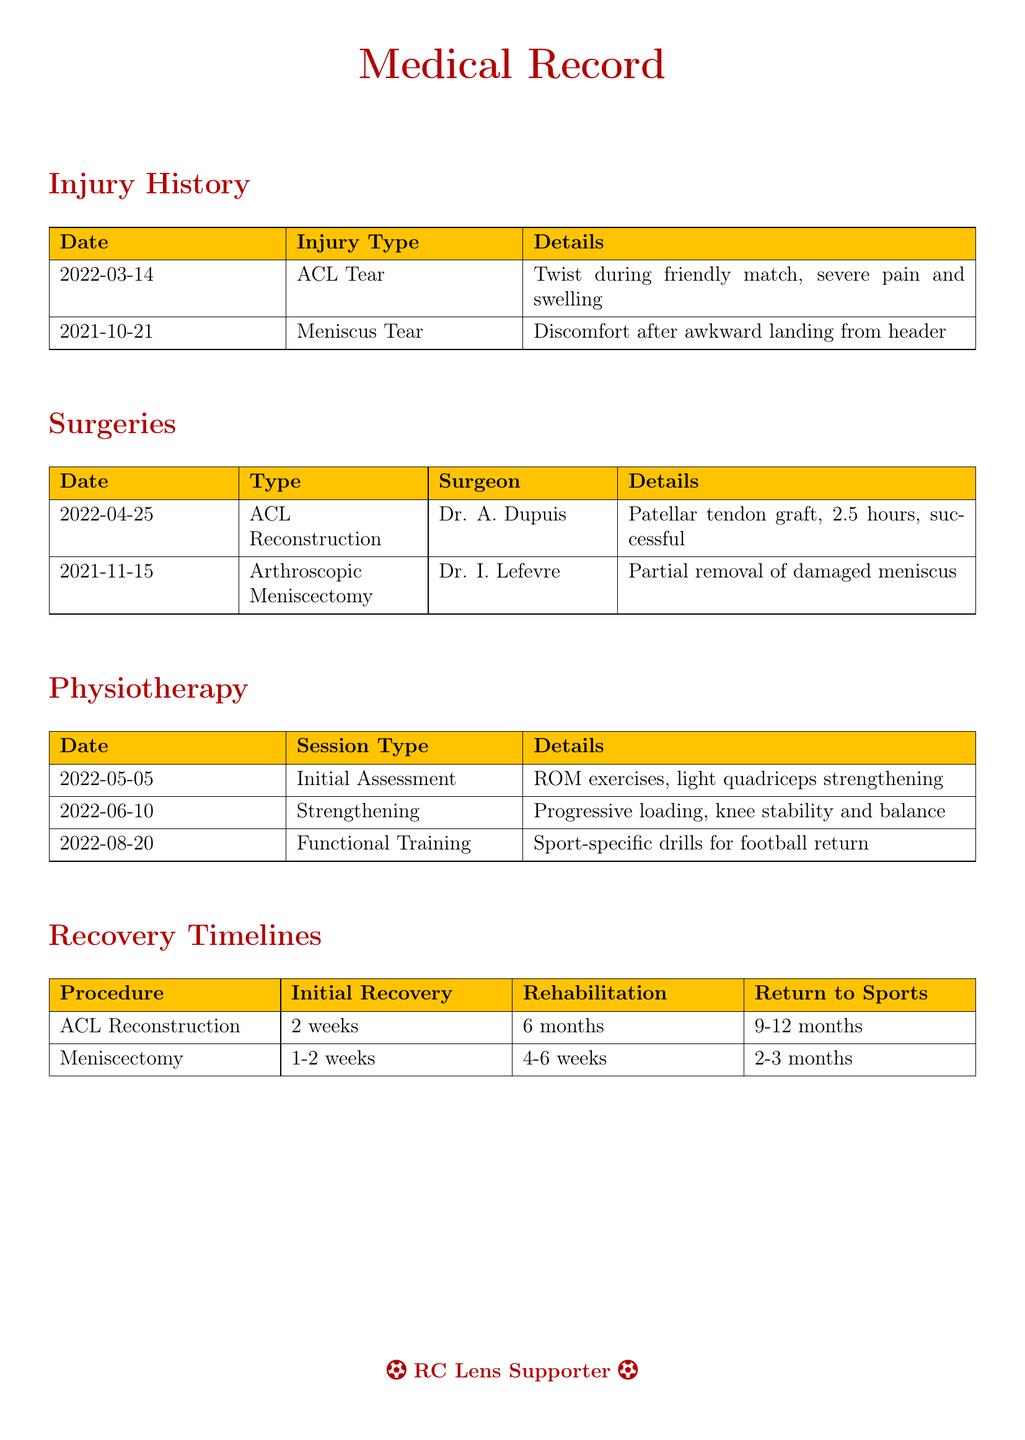What was the date of the ACL tear? The date is listed in the Injury History section of the document.
Answer: 2022-03-14 Who performed the ACL reconstruction surgery? The surgeon's name can be found in the Surgeries section.
Answer: Dr. A. Dupuis How long was the recovery timeline for meniscectomy? The recovery timeline is noted in the Recovery Timelines section.
Answer: 2-3 months What session type was conducted on 2022-06-10? The session type is specified in the Physiotherapy section by date.
Answer: Strengthening What kind of graft was used in the ACL reconstruction? The details regarding the graft type are provided in the Surgeries section.
Answer: Patellar tendon graft What was the initial recovery period for ACL reconstruction? This information is summarized in the Recovery Timelines section.
Answer: 2 weeks What type of injury occurred on 2021-10-21? The type of injury is listed in the Injury History section.
Answer: Meniscus Tear How many physiotherapy sessions were conducted before returning to sports post-ACL reconstruction? This requires analyzing the details and timelines provided in the Physiotherapy and Recovery sections.
Answer: 3 sessions 